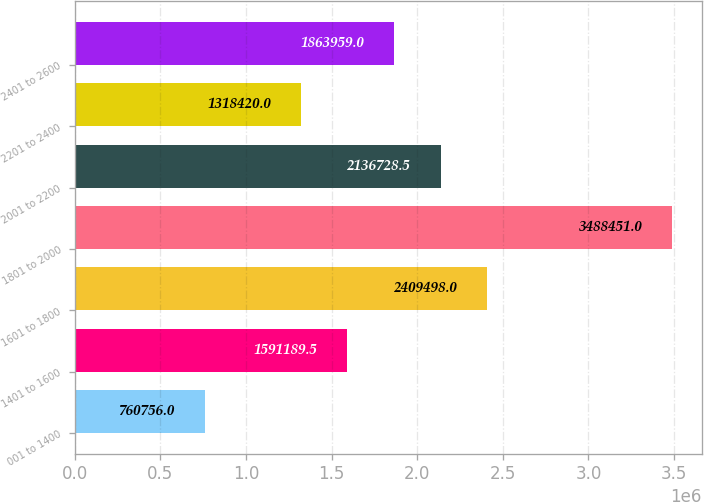Convert chart to OTSL. <chart><loc_0><loc_0><loc_500><loc_500><bar_chart><fcel>001 to 1400<fcel>1401 to 1600<fcel>1601 to 1800<fcel>1801 to 2000<fcel>2001 to 2200<fcel>2201 to 2400<fcel>2401 to 2600<nl><fcel>760756<fcel>1.59119e+06<fcel>2.4095e+06<fcel>3.48845e+06<fcel>2.13673e+06<fcel>1.31842e+06<fcel>1.86396e+06<nl></chart> 